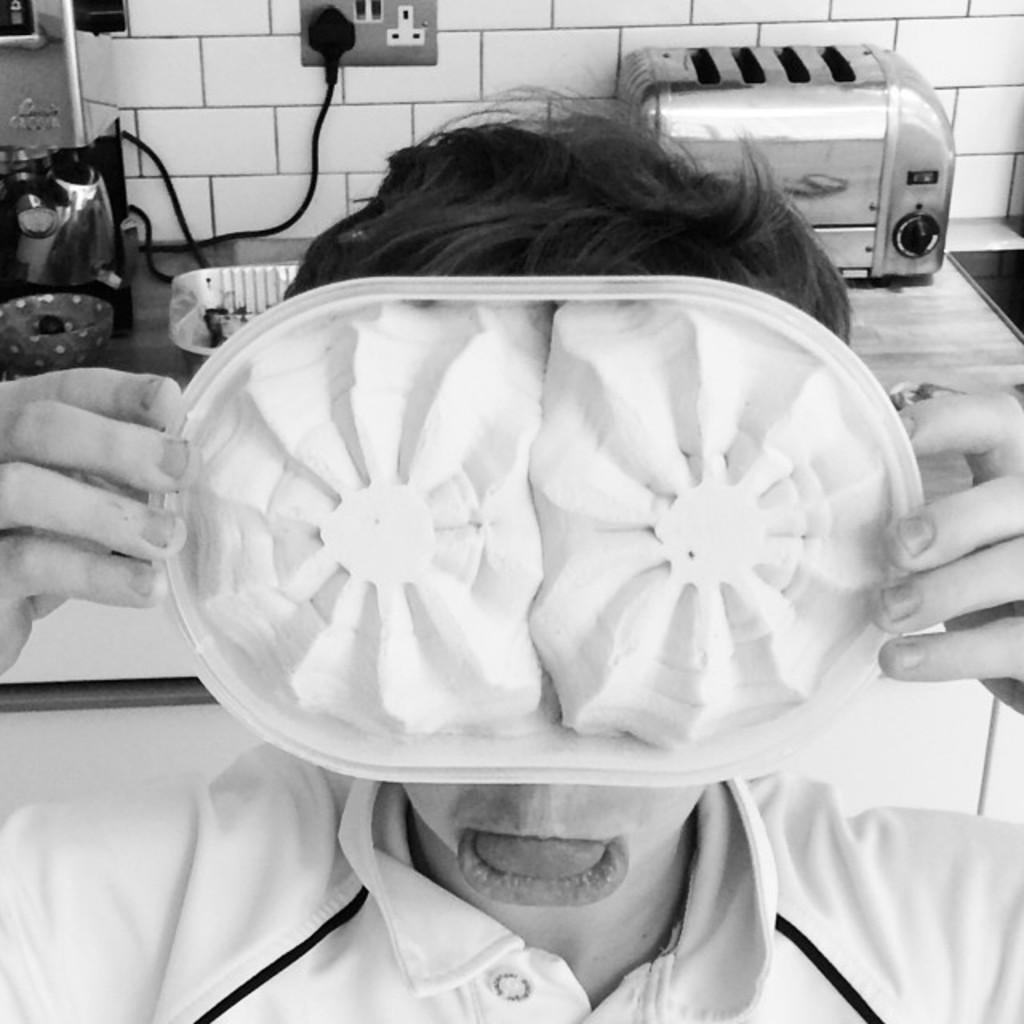How would you summarize this image in a sentence or two? There is a person holding a plate near a table on which, there is a tray, bowl, heater and other objects. In the background, there is white color tiles wall. 